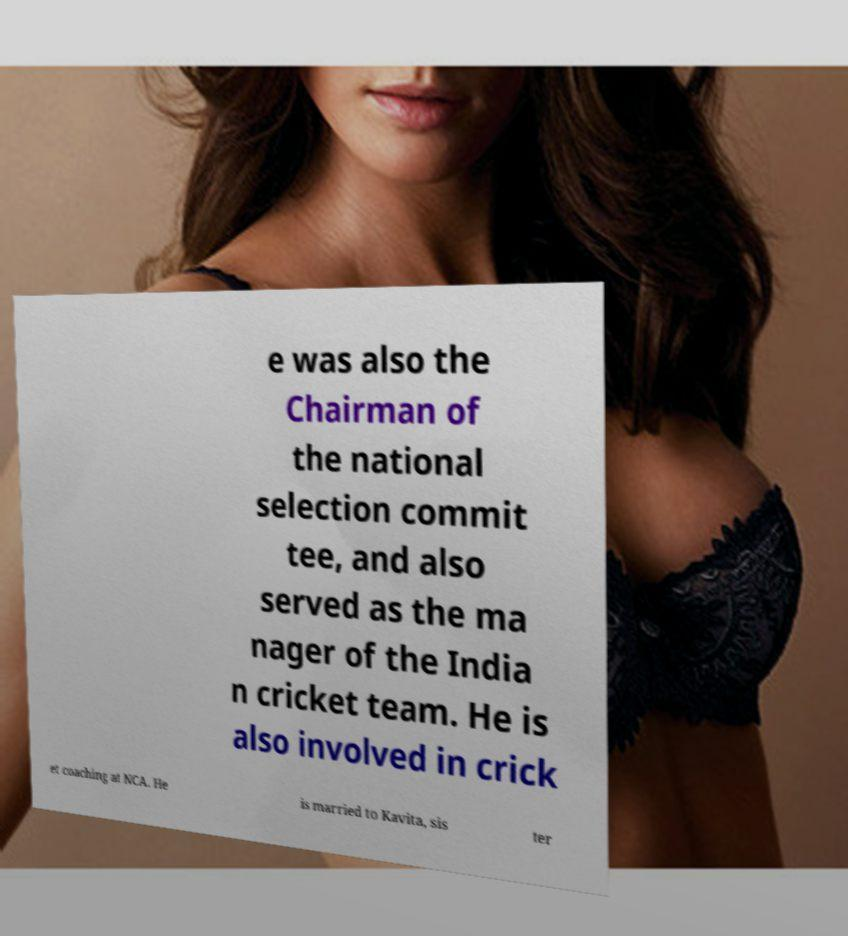Please read and relay the text visible in this image. What does it say? e was also the Chairman of the national selection commit tee, and also served as the ma nager of the India n cricket team. He is also involved in crick et coaching at NCA. He is married to Kavita, sis ter 